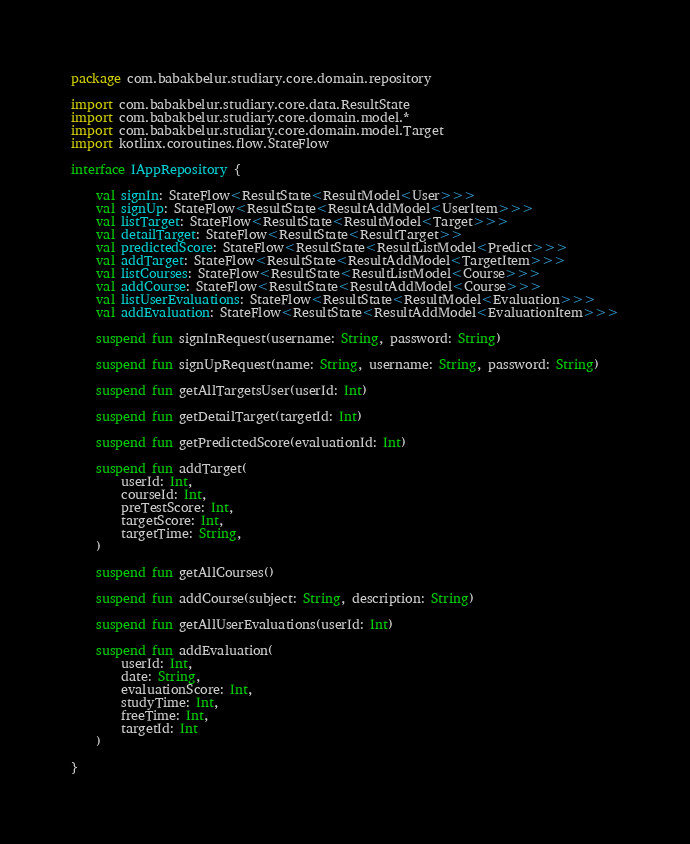<code> <loc_0><loc_0><loc_500><loc_500><_Kotlin_>package com.babakbelur.studiary.core.domain.repository

import com.babakbelur.studiary.core.data.ResultState
import com.babakbelur.studiary.core.domain.model.*
import com.babakbelur.studiary.core.domain.model.Target
import kotlinx.coroutines.flow.StateFlow

interface IAppRepository {

    val signIn: StateFlow<ResultState<ResultModel<User>>>
    val signUp: StateFlow<ResultState<ResultAddModel<UserItem>>>
    val listTarget: StateFlow<ResultState<ResultModel<Target>>>
    val detailTarget: StateFlow<ResultState<ResultTarget>>
    val predictedScore: StateFlow<ResultState<ResultListModel<Predict>>>
    val addTarget: StateFlow<ResultState<ResultAddModel<TargetItem>>>
    val listCourses: StateFlow<ResultState<ResultListModel<Course>>>
    val addCourse: StateFlow<ResultState<ResultAddModel<Course>>>
    val listUserEvaluations: StateFlow<ResultState<ResultModel<Evaluation>>>
    val addEvaluation: StateFlow<ResultState<ResultAddModel<EvaluationItem>>>

    suspend fun signInRequest(username: String, password: String)

    suspend fun signUpRequest(name: String, username: String, password: String)

    suspend fun getAllTargetsUser(userId: Int)

    suspend fun getDetailTarget(targetId: Int)

    suspend fun getPredictedScore(evaluationId: Int)

    suspend fun addTarget(
        userId: Int,
        courseId: Int,
        preTestScore: Int,
        targetScore: Int,
        targetTime: String,
    )

    suspend fun getAllCourses()

    suspend fun addCourse(subject: String, description: String)

    suspend fun getAllUserEvaluations(userId: Int)

    suspend fun addEvaluation(
        userId: Int,
        date: String,
        evaluationScore: Int,
        studyTime: Int,
        freeTime: Int,
        targetId: Int
    )

}</code> 